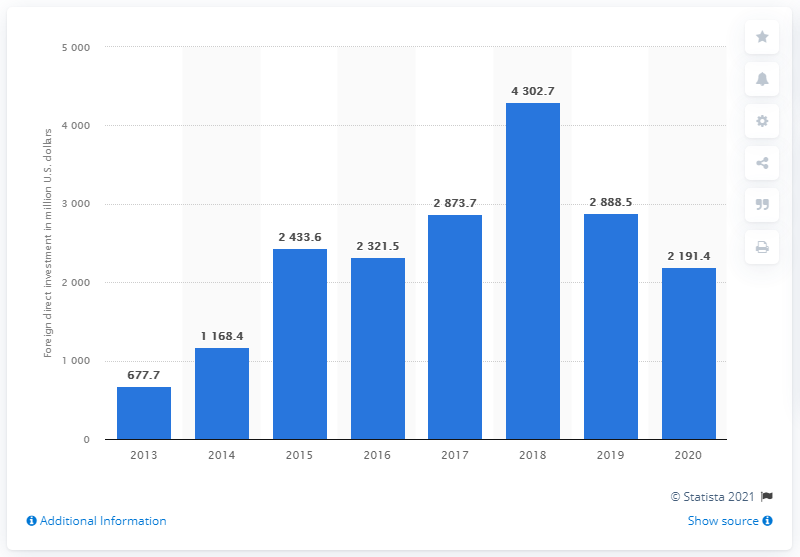Point out several critical features in this image. In 2020, the amount of foreign direct investment in real estate and business services in Indonesia was approximately 2,191.4. 